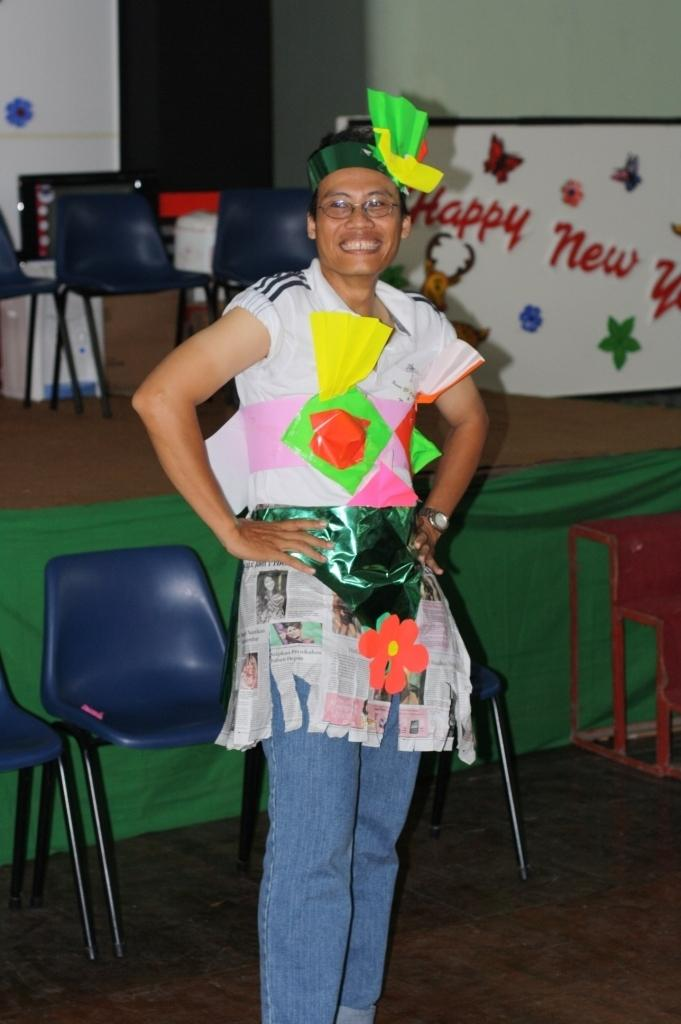Who is present in the image? There is a woman in the image. What is the woman's facial expression? The woman is smiling. What is the woman's position in the image? The woman is standing on the floor. What can be seen in the background of the image? There are chairs, cardboard cartons, decor, and walls visible in the background. What type of badge is the woman wearing in the image? There is no badge visible on the woman in the image. What kind of insect can be seen crawling on the wall in the image? There are no insects present in the image; only the woman, chairs, cardboard cartons, decor, and walls can be seen. 